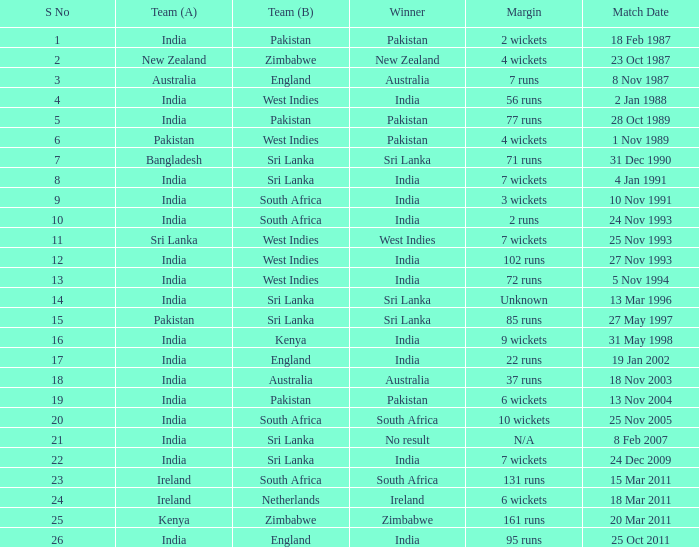Who won the match when the margin was 131 runs? South Africa. 